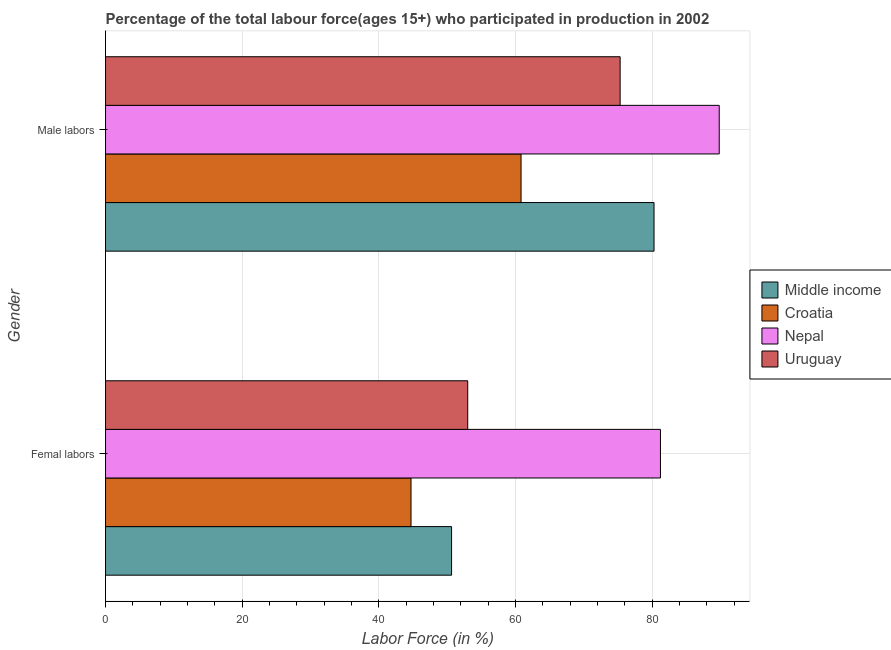How many different coloured bars are there?
Your response must be concise. 4. How many groups of bars are there?
Keep it short and to the point. 2. Are the number of bars per tick equal to the number of legend labels?
Ensure brevity in your answer.  Yes. Are the number of bars on each tick of the Y-axis equal?
Ensure brevity in your answer.  Yes. How many bars are there on the 1st tick from the top?
Ensure brevity in your answer.  4. How many bars are there on the 2nd tick from the bottom?
Provide a short and direct response. 4. What is the label of the 1st group of bars from the top?
Provide a succinct answer. Male labors. What is the percentage of female labor force in Middle income?
Your answer should be compact. 50.64. Across all countries, what is the maximum percentage of female labor force?
Offer a terse response. 81.2. Across all countries, what is the minimum percentage of female labor force?
Your answer should be very brief. 44.7. In which country was the percentage of female labor force maximum?
Give a very brief answer. Nepal. In which country was the percentage of female labor force minimum?
Offer a terse response. Croatia. What is the total percentage of male labour force in the graph?
Your answer should be very brief. 306.16. What is the difference between the percentage of female labor force in Uruguay and that in Croatia?
Give a very brief answer. 8.3. What is the difference between the percentage of female labor force in Croatia and the percentage of male labour force in Middle income?
Make the answer very short. -35.56. What is the average percentage of female labor force per country?
Your answer should be compact. 57.38. What is the difference between the percentage of male labour force and percentage of female labor force in Uruguay?
Ensure brevity in your answer.  22.3. In how many countries, is the percentage of female labor force greater than 76 %?
Your response must be concise. 1. What is the ratio of the percentage of female labor force in Croatia to that in Middle income?
Make the answer very short. 0.88. In how many countries, is the percentage of female labor force greater than the average percentage of female labor force taken over all countries?
Your answer should be very brief. 1. What does the 1st bar from the top in Male labors represents?
Ensure brevity in your answer.  Uruguay. What does the 3rd bar from the bottom in Femal labors represents?
Your answer should be compact. Nepal. How many countries are there in the graph?
Give a very brief answer. 4. Are the values on the major ticks of X-axis written in scientific E-notation?
Provide a short and direct response. No. Does the graph contain any zero values?
Offer a very short reply. No. Does the graph contain grids?
Make the answer very short. Yes. What is the title of the graph?
Offer a terse response. Percentage of the total labour force(ages 15+) who participated in production in 2002. What is the label or title of the Y-axis?
Offer a very short reply. Gender. What is the Labor Force (in %) in Middle income in Femal labors?
Make the answer very short. 50.64. What is the Labor Force (in %) in Croatia in Femal labors?
Provide a succinct answer. 44.7. What is the Labor Force (in %) of Nepal in Femal labors?
Offer a very short reply. 81.2. What is the Labor Force (in %) in Middle income in Male labors?
Your response must be concise. 80.26. What is the Labor Force (in %) of Croatia in Male labors?
Keep it short and to the point. 60.8. What is the Labor Force (in %) in Nepal in Male labors?
Your response must be concise. 89.8. What is the Labor Force (in %) of Uruguay in Male labors?
Offer a terse response. 75.3. Across all Gender, what is the maximum Labor Force (in %) in Middle income?
Ensure brevity in your answer.  80.26. Across all Gender, what is the maximum Labor Force (in %) of Croatia?
Make the answer very short. 60.8. Across all Gender, what is the maximum Labor Force (in %) of Nepal?
Your response must be concise. 89.8. Across all Gender, what is the maximum Labor Force (in %) of Uruguay?
Offer a very short reply. 75.3. Across all Gender, what is the minimum Labor Force (in %) of Middle income?
Provide a succinct answer. 50.64. Across all Gender, what is the minimum Labor Force (in %) in Croatia?
Your answer should be very brief. 44.7. Across all Gender, what is the minimum Labor Force (in %) in Nepal?
Your answer should be very brief. 81.2. Across all Gender, what is the minimum Labor Force (in %) in Uruguay?
Make the answer very short. 53. What is the total Labor Force (in %) of Middle income in the graph?
Keep it short and to the point. 130.9. What is the total Labor Force (in %) in Croatia in the graph?
Ensure brevity in your answer.  105.5. What is the total Labor Force (in %) in Nepal in the graph?
Offer a terse response. 171. What is the total Labor Force (in %) in Uruguay in the graph?
Offer a terse response. 128.3. What is the difference between the Labor Force (in %) in Middle income in Femal labors and that in Male labors?
Your response must be concise. -29.62. What is the difference between the Labor Force (in %) in Croatia in Femal labors and that in Male labors?
Your answer should be compact. -16.1. What is the difference between the Labor Force (in %) of Uruguay in Femal labors and that in Male labors?
Offer a terse response. -22.3. What is the difference between the Labor Force (in %) of Middle income in Femal labors and the Labor Force (in %) of Croatia in Male labors?
Your response must be concise. -10.16. What is the difference between the Labor Force (in %) in Middle income in Femal labors and the Labor Force (in %) in Nepal in Male labors?
Your response must be concise. -39.16. What is the difference between the Labor Force (in %) of Middle income in Femal labors and the Labor Force (in %) of Uruguay in Male labors?
Offer a very short reply. -24.66. What is the difference between the Labor Force (in %) of Croatia in Femal labors and the Labor Force (in %) of Nepal in Male labors?
Your answer should be compact. -45.1. What is the difference between the Labor Force (in %) in Croatia in Femal labors and the Labor Force (in %) in Uruguay in Male labors?
Keep it short and to the point. -30.6. What is the average Labor Force (in %) in Middle income per Gender?
Your answer should be very brief. 65.45. What is the average Labor Force (in %) of Croatia per Gender?
Offer a terse response. 52.75. What is the average Labor Force (in %) of Nepal per Gender?
Provide a succinct answer. 85.5. What is the average Labor Force (in %) in Uruguay per Gender?
Offer a terse response. 64.15. What is the difference between the Labor Force (in %) of Middle income and Labor Force (in %) of Croatia in Femal labors?
Your answer should be very brief. 5.94. What is the difference between the Labor Force (in %) of Middle income and Labor Force (in %) of Nepal in Femal labors?
Your answer should be compact. -30.56. What is the difference between the Labor Force (in %) of Middle income and Labor Force (in %) of Uruguay in Femal labors?
Ensure brevity in your answer.  -2.36. What is the difference between the Labor Force (in %) of Croatia and Labor Force (in %) of Nepal in Femal labors?
Offer a terse response. -36.5. What is the difference between the Labor Force (in %) in Croatia and Labor Force (in %) in Uruguay in Femal labors?
Give a very brief answer. -8.3. What is the difference between the Labor Force (in %) in Nepal and Labor Force (in %) in Uruguay in Femal labors?
Make the answer very short. 28.2. What is the difference between the Labor Force (in %) of Middle income and Labor Force (in %) of Croatia in Male labors?
Offer a very short reply. 19.46. What is the difference between the Labor Force (in %) in Middle income and Labor Force (in %) in Nepal in Male labors?
Give a very brief answer. -9.54. What is the difference between the Labor Force (in %) in Middle income and Labor Force (in %) in Uruguay in Male labors?
Your answer should be compact. 4.96. What is the difference between the Labor Force (in %) of Croatia and Labor Force (in %) of Nepal in Male labors?
Make the answer very short. -29. What is the difference between the Labor Force (in %) in Croatia and Labor Force (in %) in Uruguay in Male labors?
Your answer should be compact. -14.5. What is the ratio of the Labor Force (in %) in Middle income in Femal labors to that in Male labors?
Ensure brevity in your answer.  0.63. What is the ratio of the Labor Force (in %) in Croatia in Femal labors to that in Male labors?
Your response must be concise. 0.74. What is the ratio of the Labor Force (in %) in Nepal in Femal labors to that in Male labors?
Offer a very short reply. 0.9. What is the ratio of the Labor Force (in %) in Uruguay in Femal labors to that in Male labors?
Provide a short and direct response. 0.7. What is the difference between the highest and the second highest Labor Force (in %) in Middle income?
Keep it short and to the point. 29.62. What is the difference between the highest and the second highest Labor Force (in %) of Croatia?
Ensure brevity in your answer.  16.1. What is the difference between the highest and the second highest Labor Force (in %) in Uruguay?
Your response must be concise. 22.3. What is the difference between the highest and the lowest Labor Force (in %) of Middle income?
Ensure brevity in your answer.  29.62. What is the difference between the highest and the lowest Labor Force (in %) in Uruguay?
Keep it short and to the point. 22.3. 